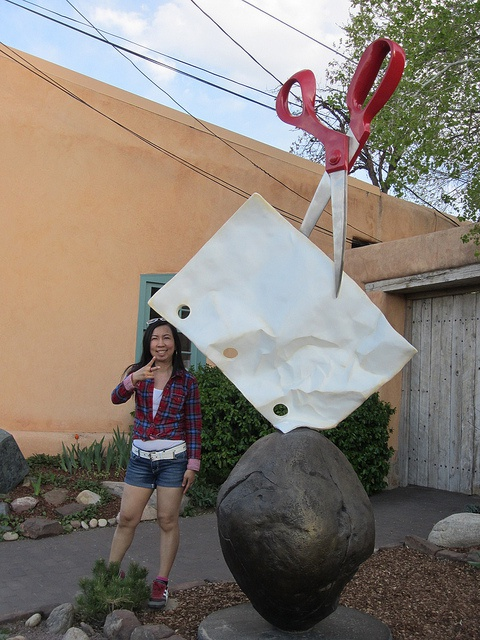Describe the objects in this image and their specific colors. I can see people in lavender, black, gray, and maroon tones and scissors in lavender, brown, maroon, darkgray, and lightgray tones in this image. 